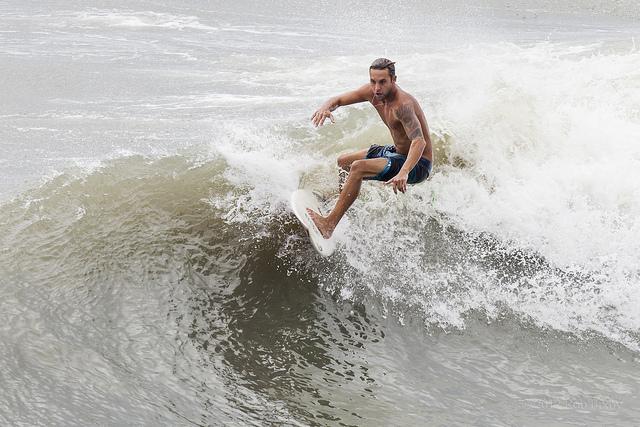Are the waves big?
Quick response, please. Yes. What is the man doing?
Give a very brief answer. Surfing. Does the man have a tattoo on his left arm?
Short answer required. Yes. What is this man wearing to protect himself?
Quick response, please. Shorts. Is the water cold?
Write a very short answer. No. 